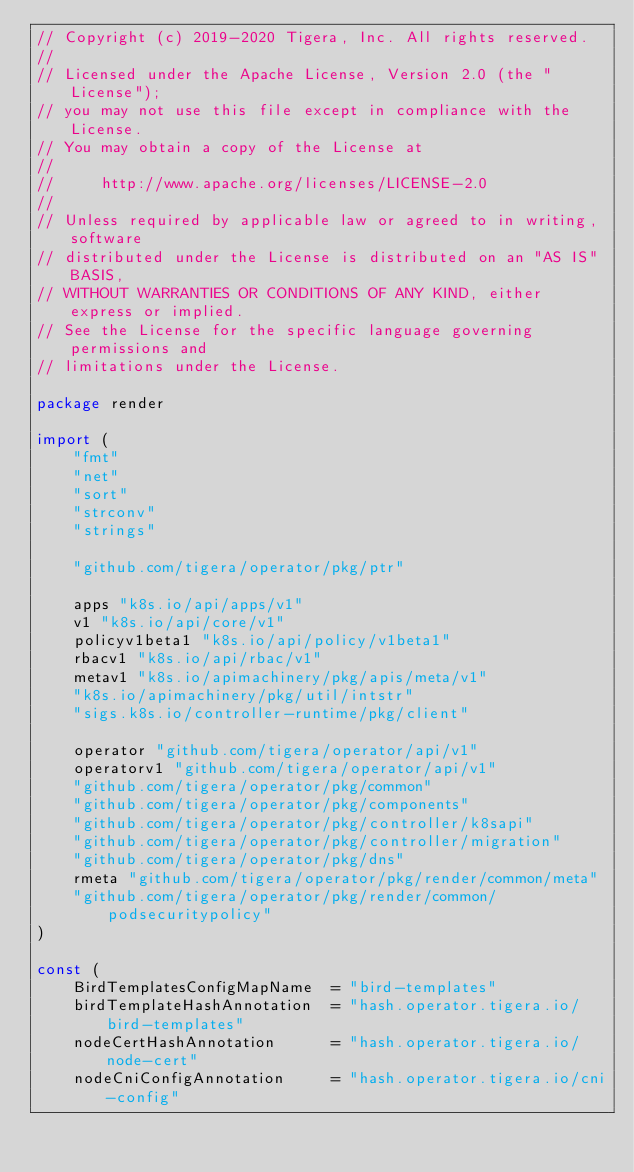Convert code to text. <code><loc_0><loc_0><loc_500><loc_500><_Go_>// Copyright (c) 2019-2020 Tigera, Inc. All rights reserved.
//
// Licensed under the Apache License, Version 2.0 (the "License");
// you may not use this file except in compliance with the License.
// You may obtain a copy of the License at
//
//     http://www.apache.org/licenses/LICENSE-2.0
//
// Unless required by applicable law or agreed to in writing, software
// distributed under the License is distributed on an "AS IS" BASIS,
// WITHOUT WARRANTIES OR CONDITIONS OF ANY KIND, either express or implied.
// See the License for the specific language governing permissions and
// limitations under the License.

package render

import (
	"fmt"
	"net"
	"sort"
	"strconv"
	"strings"

	"github.com/tigera/operator/pkg/ptr"

	apps "k8s.io/api/apps/v1"
	v1 "k8s.io/api/core/v1"
	policyv1beta1 "k8s.io/api/policy/v1beta1"
	rbacv1 "k8s.io/api/rbac/v1"
	metav1 "k8s.io/apimachinery/pkg/apis/meta/v1"
	"k8s.io/apimachinery/pkg/util/intstr"
	"sigs.k8s.io/controller-runtime/pkg/client"

	operator "github.com/tigera/operator/api/v1"
	operatorv1 "github.com/tigera/operator/api/v1"
	"github.com/tigera/operator/pkg/common"
	"github.com/tigera/operator/pkg/components"
	"github.com/tigera/operator/pkg/controller/k8sapi"
	"github.com/tigera/operator/pkg/controller/migration"
	"github.com/tigera/operator/pkg/dns"
	rmeta "github.com/tigera/operator/pkg/render/common/meta"
	"github.com/tigera/operator/pkg/render/common/podsecuritypolicy"
)

const (
	BirdTemplatesConfigMapName  = "bird-templates"
	birdTemplateHashAnnotation  = "hash.operator.tigera.io/bird-templates"
	nodeCertHashAnnotation      = "hash.operator.tigera.io/node-cert"
	nodeCniConfigAnnotation     = "hash.operator.tigera.io/cni-config"</code> 